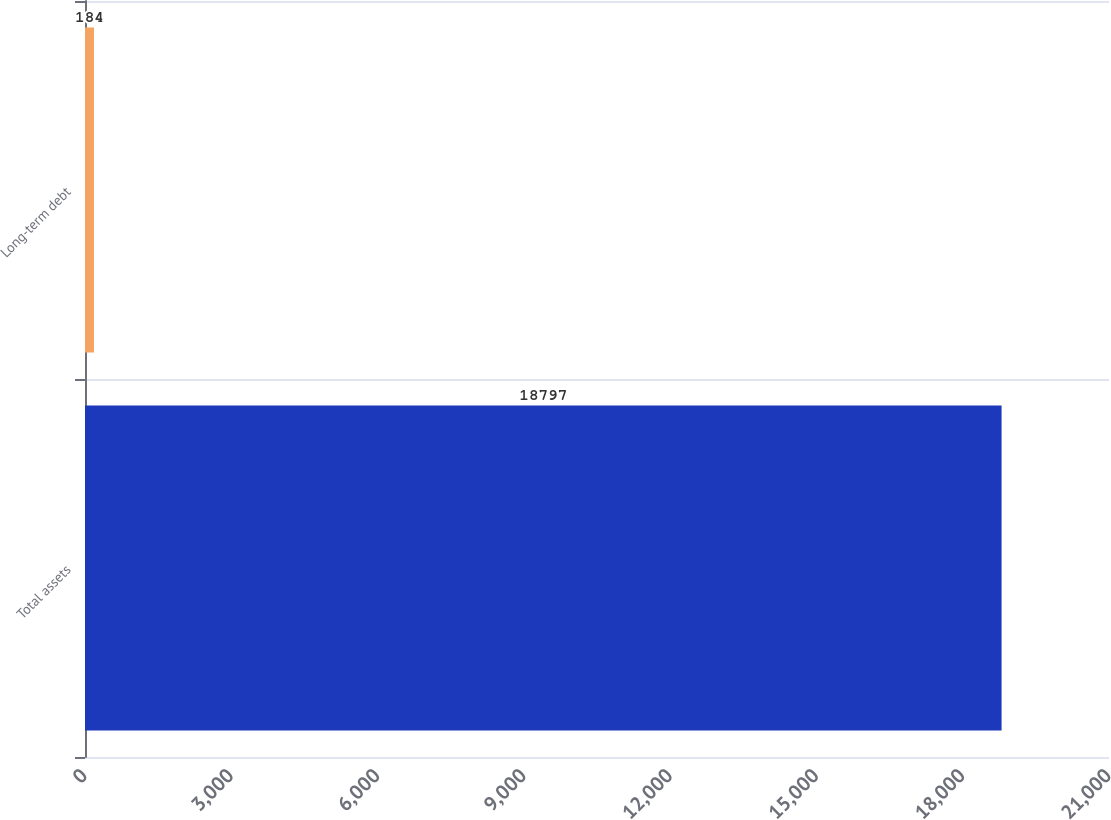Convert chart. <chart><loc_0><loc_0><loc_500><loc_500><bar_chart><fcel>Total assets<fcel>Long-term debt<nl><fcel>18797<fcel>184<nl></chart> 